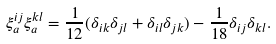Convert formula to latex. <formula><loc_0><loc_0><loc_500><loc_500>\xi _ { a } ^ { i j } \xi _ { a } ^ { k l } = \frac { 1 } { 1 2 } ( \delta _ { i k } \delta _ { j l } + \delta _ { i l } \delta _ { j k } ) - \frac { 1 } { 1 8 } \delta _ { i j } \delta _ { k l } .</formula> 